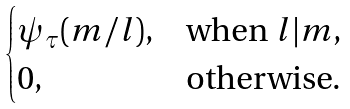Convert formula to latex. <formula><loc_0><loc_0><loc_500><loc_500>\begin{cases} \psi _ { \tau } ( m / l ) , & \text {when $l|m$,} \\ 0 , & \text {otherwise.} \end{cases}</formula> 